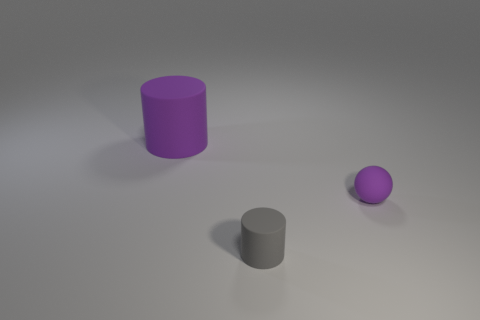Add 1 tiny green cylinders. How many objects exist? 4 Subtract all cylinders. How many objects are left? 1 Subtract all big purple things. Subtract all small spheres. How many objects are left? 1 Add 3 small things. How many small things are left? 5 Add 3 small blue shiny blocks. How many small blue shiny blocks exist? 3 Subtract 0 green spheres. How many objects are left? 3 